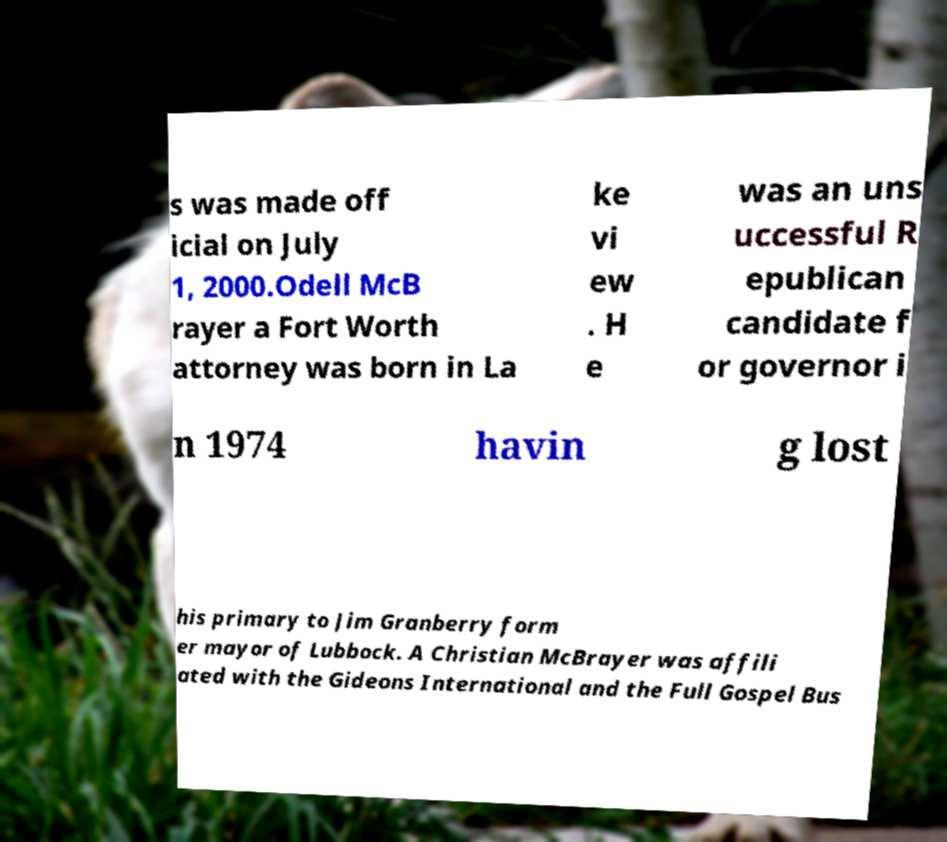I need the written content from this picture converted into text. Can you do that? s was made off icial on July 1, 2000.Odell McB rayer a Fort Worth attorney was born in La ke vi ew . H e was an uns uccessful R epublican candidate f or governor i n 1974 havin g lost his primary to Jim Granberry form er mayor of Lubbock. A Christian McBrayer was affili ated with the Gideons International and the Full Gospel Bus 